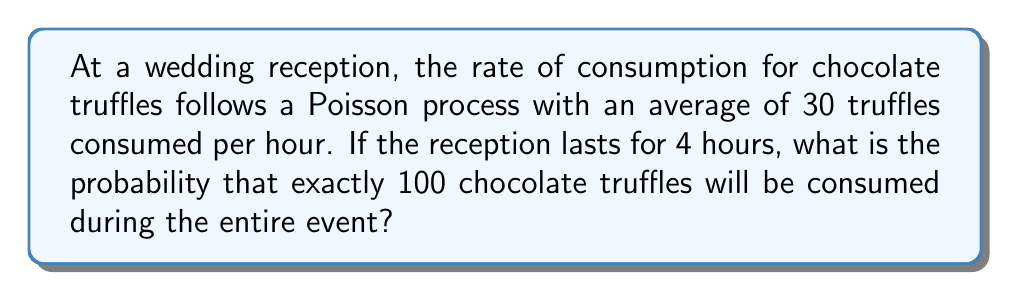Could you help me with this problem? To solve this problem, we'll use the Poisson distribution formula and follow these steps:

1. Identify the parameters:
   - Rate (λ) = 30 truffles per hour
   - Time (t) = 4 hours
   - Number of events (k) = 100 truffles

2. Calculate the mean number of truffles consumed in 4 hours:
   μ = λt = 30 * 4 = 120 truffles

3. Use the Poisson probability mass function:
   $$P(X = k) = \frac{e^{-μ} μ^k}{k!}$$

   Where:
   - e is Euler's number (approximately 2.71828)
   - μ is the mean number of events
   - k is the number of events we're interested in

4. Substitute the values into the formula:
   $$P(X = 100) = \frac{e^{-120} 120^{100}}{100!}$$

5. Calculate the result:
   $$P(X = 100) ≈ 0.0259$$

This means there is approximately a 2.59% chance that exactly 100 chocolate truffles will be consumed during the 4-hour reception.
Answer: 0.0259 or 2.59% 